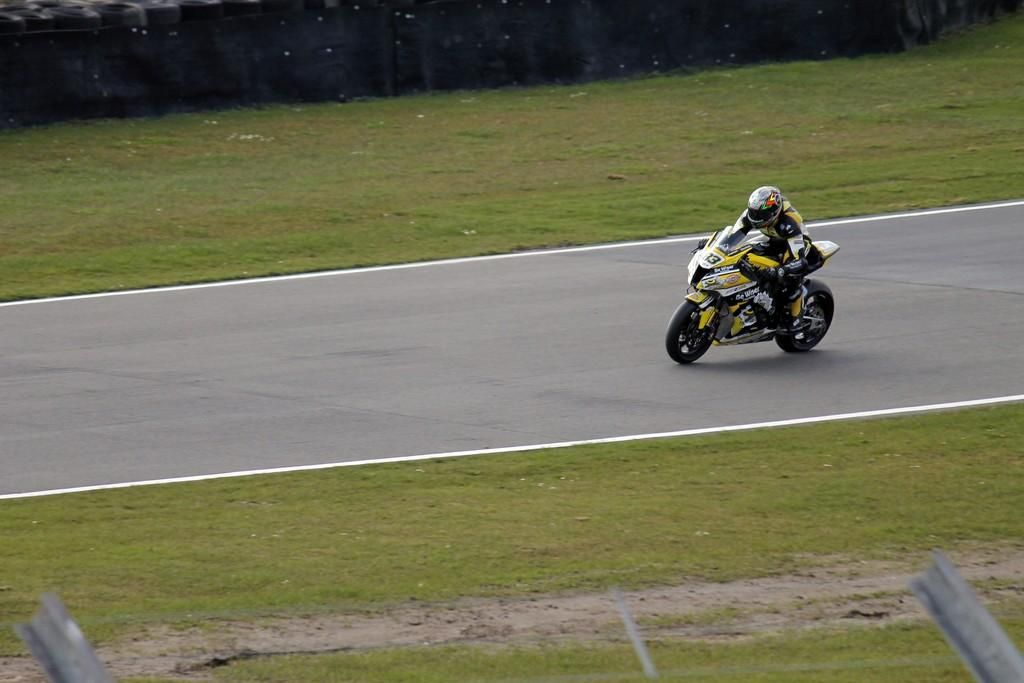What is the person in the image doing? The person is riding a bike in the image. What color is the bike the person is riding? The bike is yellow. What type of terrain can be seen in the image? There is grass in the image. What color is the grass? The grass is green. Are there any visible signs of flesh or bears in the image? No, there are no visible signs of flesh or bears in the image. Is there any lace present in the image? No, there is no lace present in the image. 